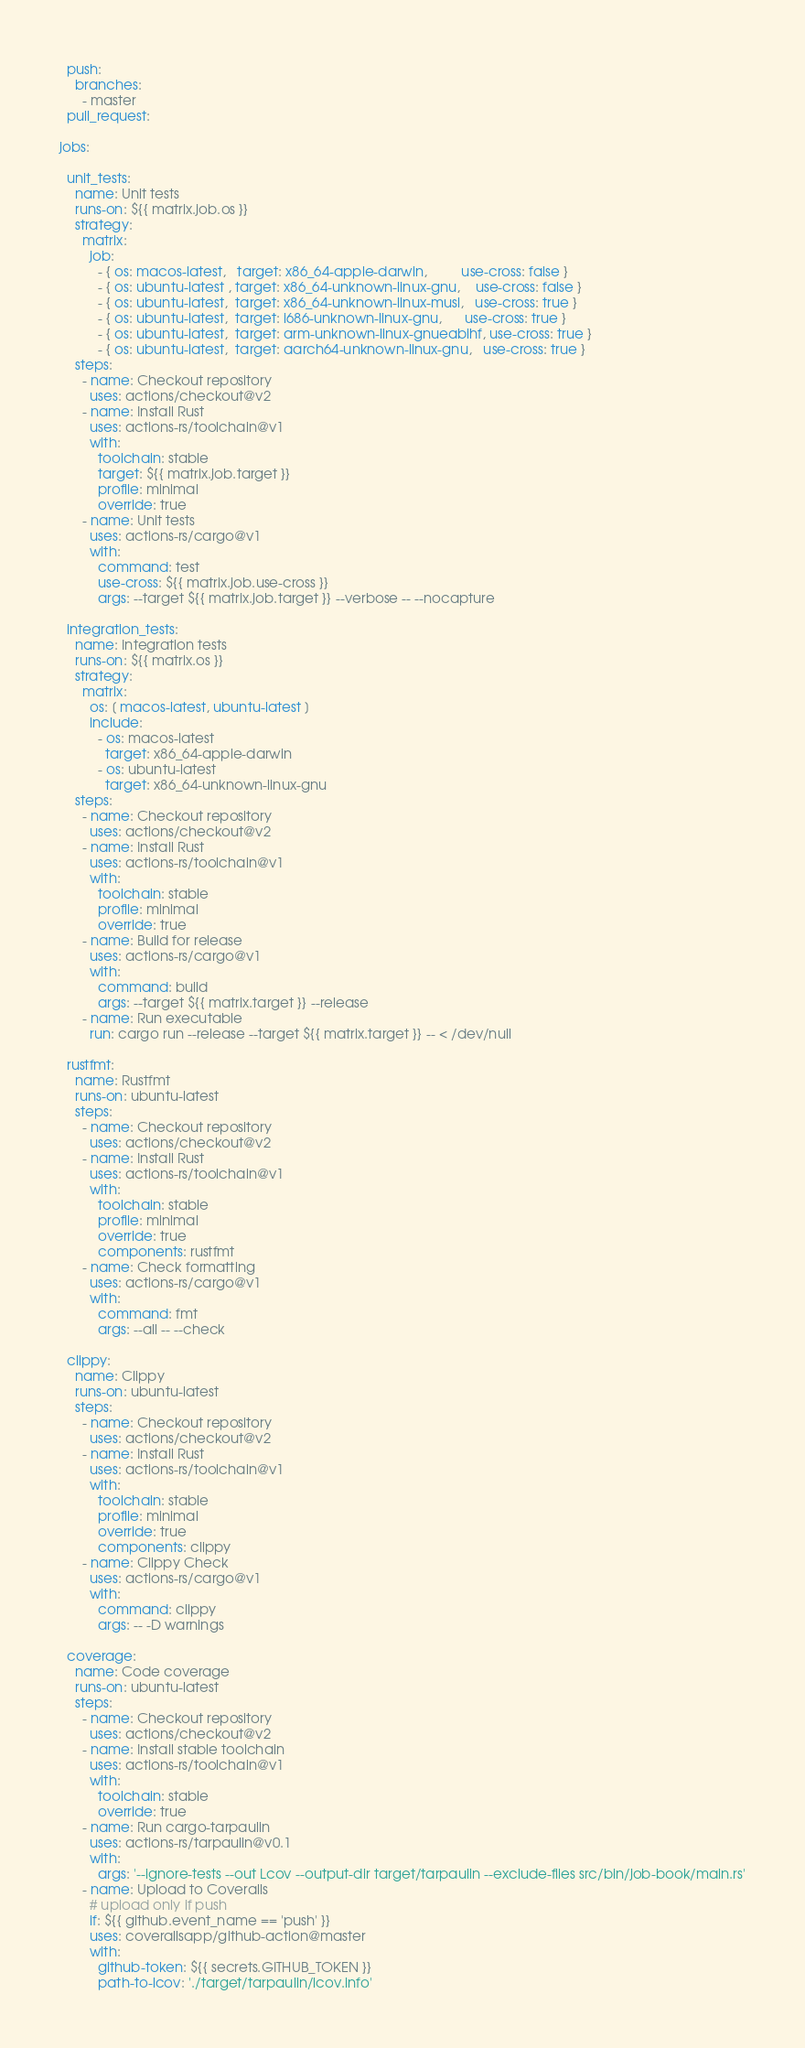Convert code to text. <code><loc_0><loc_0><loc_500><loc_500><_YAML_>  push:
    branches:
      - master
  pull_request:

jobs:

  unit_tests:
    name: Unit tests
    runs-on: ${{ matrix.job.os }}
    strategy:
      matrix:
        job:
          - { os: macos-latest,   target: x86_64-apple-darwin,         use-cross: false }
          - { os: ubuntu-latest , target: x86_64-unknown-linux-gnu,    use-cross: false }
          - { os: ubuntu-latest,  target: x86_64-unknown-linux-musl,   use-cross: true }
          - { os: ubuntu-latest,  target: i686-unknown-linux-gnu,      use-cross: true }
          - { os: ubuntu-latest,  target: arm-unknown-linux-gnueabihf, use-cross: true }
          - { os: ubuntu-latest,  target: aarch64-unknown-linux-gnu,   use-cross: true }
    steps:
      - name: Checkout repository
        uses: actions/checkout@v2
      - name: Install Rust
        uses: actions-rs/toolchain@v1
        with:
          toolchain: stable
          target: ${{ matrix.job.target }}
          profile: minimal
          override: true
      - name: Unit tests
        uses: actions-rs/cargo@v1
        with:
          command: test
          use-cross: ${{ matrix.job.use-cross }}
          args: --target ${{ matrix.job.target }} --verbose -- --nocapture

  integration_tests:
    name: Integration tests
    runs-on: ${{ matrix.os }}
    strategy:
      matrix:
        os: [ macos-latest, ubuntu-latest ]
        include:
          - os: macos-latest
            target: x86_64-apple-darwin
          - os: ubuntu-latest
            target: x86_64-unknown-linux-gnu
    steps:
      - name: Checkout repository
        uses: actions/checkout@v2
      - name: Install Rust
        uses: actions-rs/toolchain@v1
        with:
          toolchain: stable
          profile: minimal
          override: true
      - name: Build for release
        uses: actions-rs/cargo@v1
        with:
          command: build
          args: --target ${{ matrix.target }} --release
      - name: Run executable
        run: cargo run --release --target ${{ matrix.target }} -- < /dev/null

  rustfmt:
    name: Rustfmt
    runs-on: ubuntu-latest
    steps:
      - name: Checkout repository
        uses: actions/checkout@v2
      - name: Install Rust
        uses: actions-rs/toolchain@v1
        with:
          toolchain: stable
          profile: minimal
          override: true
          components: rustfmt
      - name: Check formatting
        uses: actions-rs/cargo@v1
        with:
          command: fmt
          args: --all -- --check

  clippy:
    name: Clippy
    runs-on: ubuntu-latest
    steps:
      - name: Checkout repository
        uses: actions/checkout@v2
      - name: Install Rust
        uses: actions-rs/toolchain@v1
        with:
          toolchain: stable
          profile: minimal
          override: true
          components: clippy
      - name: Clippy Check
        uses: actions-rs/cargo@v1
        with:
          command: clippy
          args: -- -D warnings

  coverage:
    name: Code coverage
    runs-on: ubuntu-latest
    steps:
      - name: Checkout repository
        uses: actions/checkout@v2
      - name: Install stable toolchain
        uses: actions-rs/toolchain@v1
        with:
          toolchain: stable
          override: true
      - name: Run cargo-tarpaulin
        uses: actions-rs/tarpaulin@v0.1
        with:
          args: '--ignore-tests --out Lcov --output-dir target/tarpaulin --exclude-files src/bin/job-book/main.rs'
      - name: Upload to Coveralls
        # upload only if push
        if: ${{ github.event_name == 'push' }}
        uses: coverallsapp/github-action@master
        with:
          github-token: ${{ secrets.GITHUB_TOKEN }}
          path-to-lcov: './target/tarpaulin/lcov.info'
</code> 